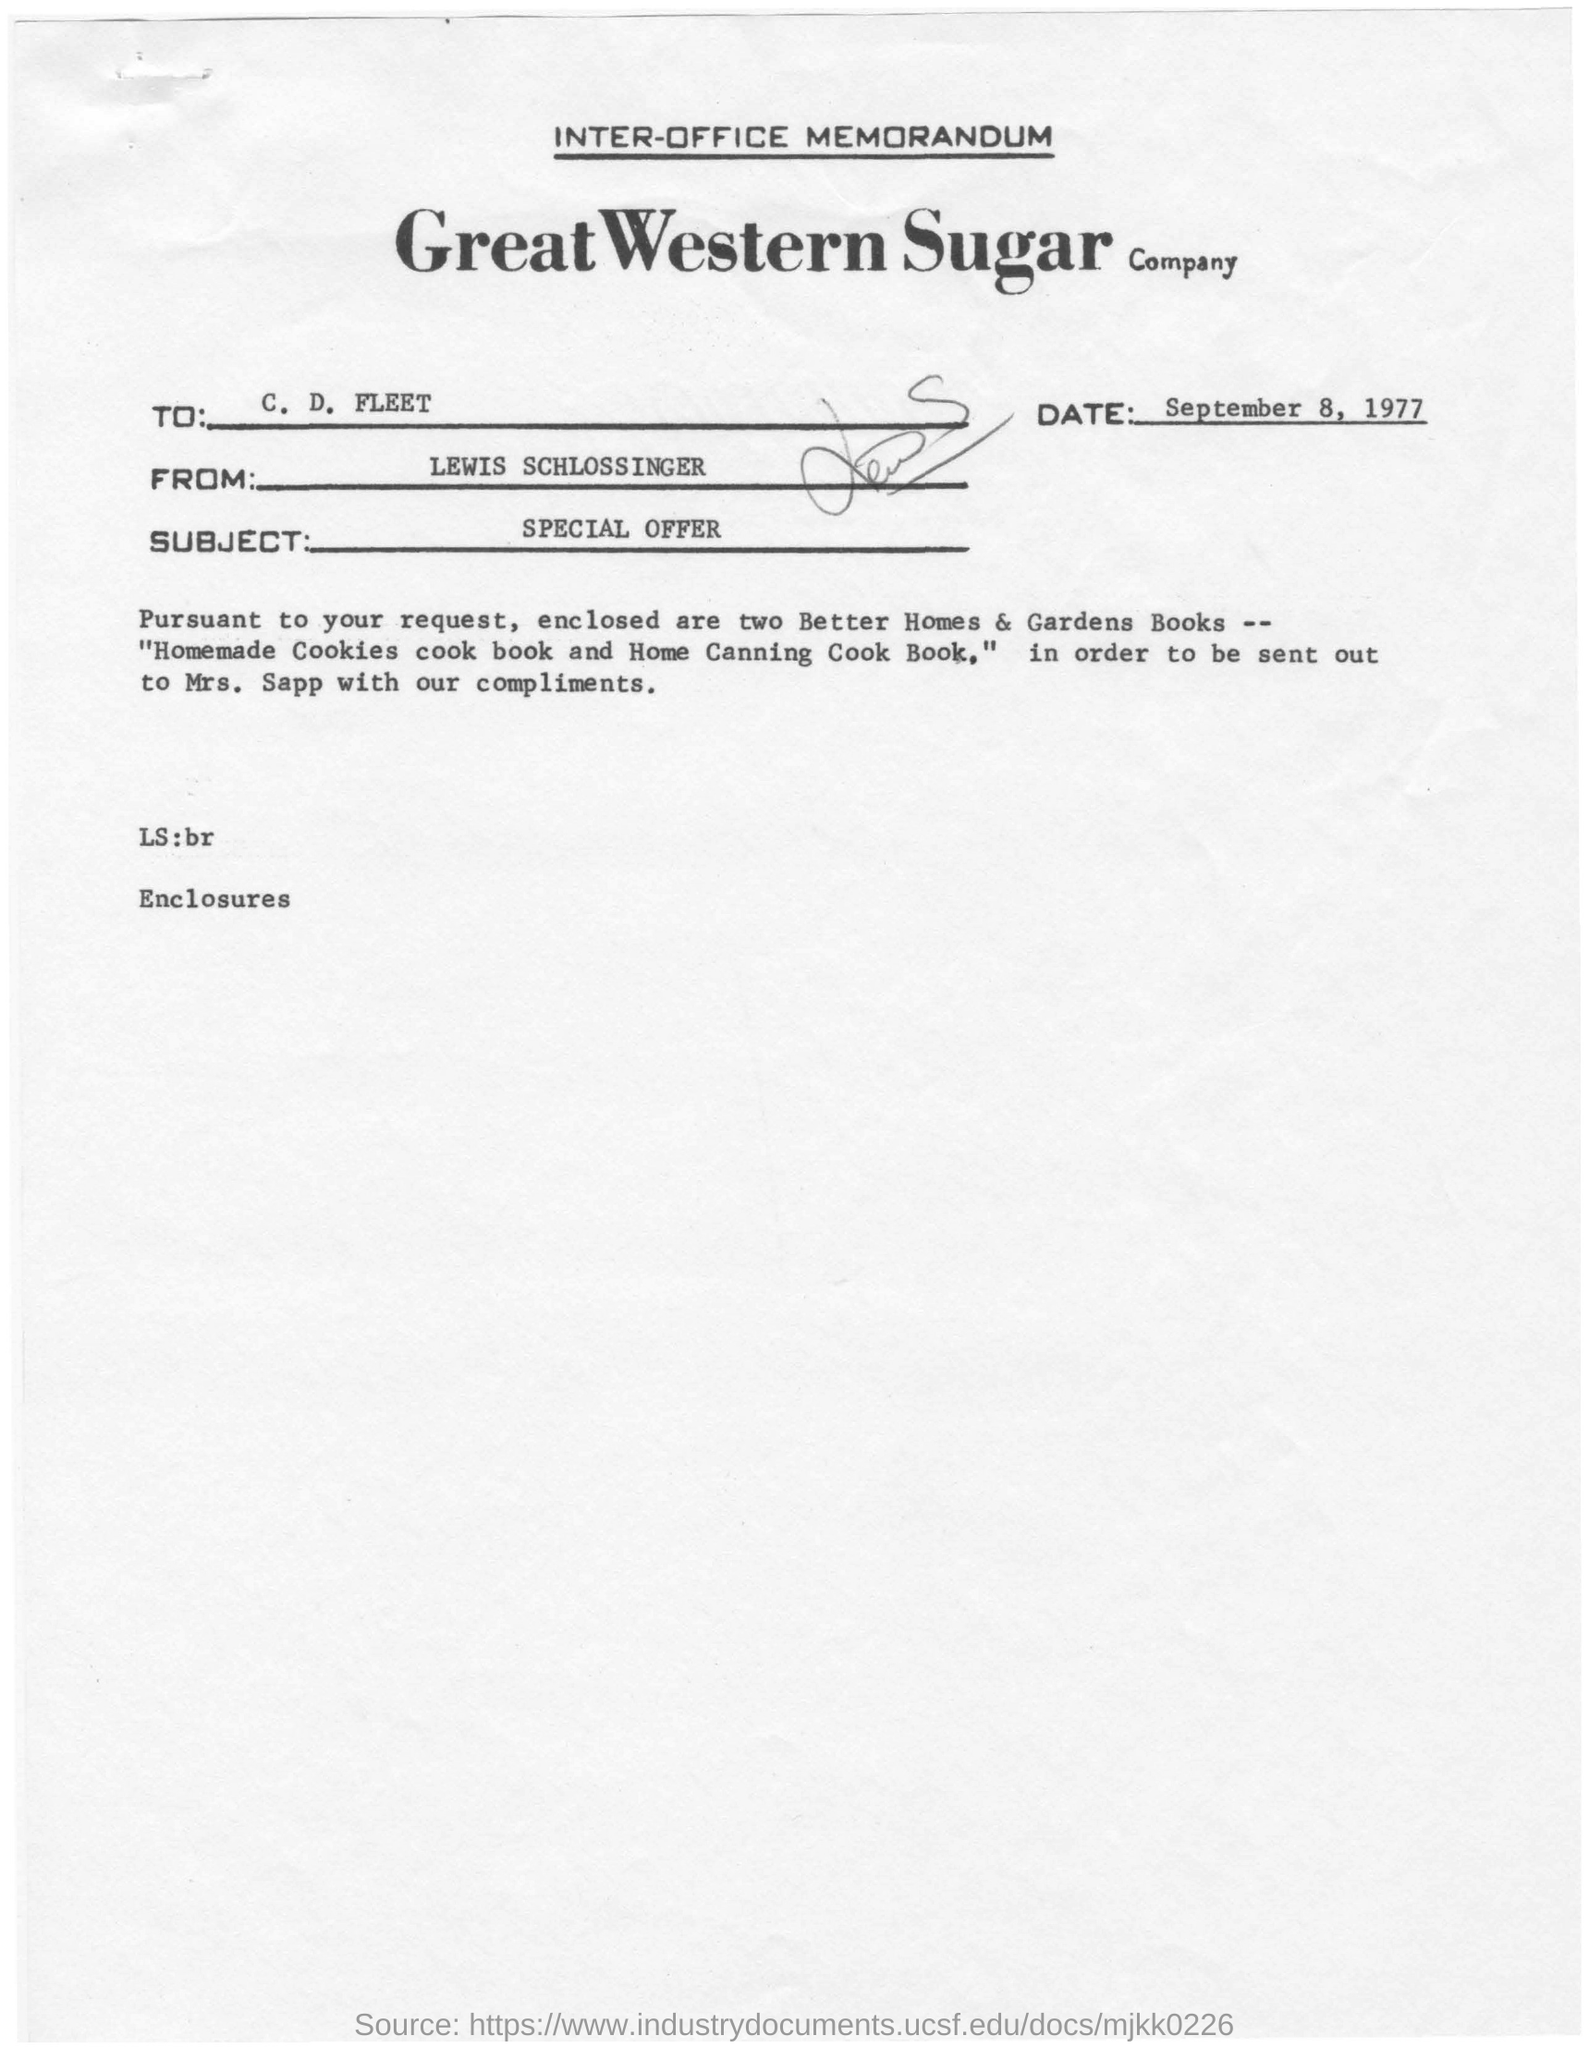What is written in top of the document ?
Provide a succinct answer. INTER-OFFICE MEMORANDUM. What is the Company Name ?
Give a very brief answer. GREAT WESTERN SUGAR COMPANY. Who sent this ?
Provide a succinct answer. LEWIS SCHLOSSINGER. Who is the recipient ?
Make the answer very short. C. D. FLEET. What is the date mentioned in the top of the document ?
Ensure brevity in your answer.  September 8, 1977. What is the Subject Line of the document ?
Make the answer very short. SPECIAL OFFER. 